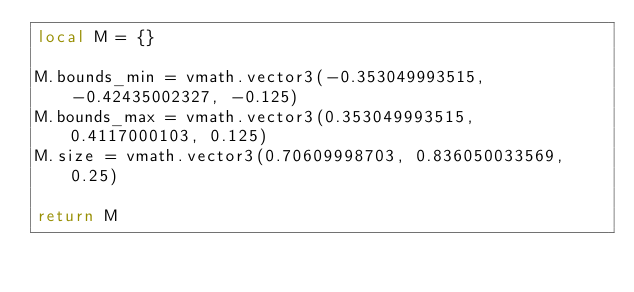Convert code to text. <code><loc_0><loc_0><loc_500><loc_500><_Lua_>local M = {}

M.bounds_min = vmath.vector3(-0.353049993515, -0.42435002327, -0.125)
M.bounds_max = vmath.vector3(0.353049993515, 0.4117000103, 0.125)
M.size = vmath.vector3(0.70609998703, 0.836050033569, 0.25)

return M
</code> 